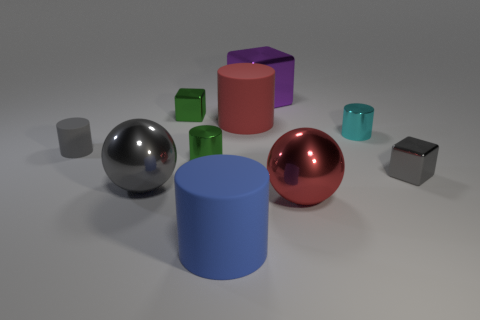Does the big sphere to the left of the large red metal ball have the same material as the tiny gray cylinder?
Provide a short and direct response. No. What is the material of the tiny cylinder that is on the right side of the tiny gray matte cylinder and to the left of the purple cube?
Your answer should be very brief. Metal. What color is the matte object that is to the left of the tiny object that is behind the red rubber object?
Give a very brief answer. Gray. What material is the gray object that is the same shape as the red metallic thing?
Offer a terse response. Metal. There is a tiny thing that is to the left of the metallic object left of the small green metal thing behind the small matte thing; what color is it?
Give a very brief answer. Gray. What number of objects are large shiny cubes or tiny purple rubber things?
Provide a succinct answer. 1. How many small brown shiny objects have the same shape as the purple thing?
Your response must be concise. 0. Is the green cube made of the same material as the gray thing that is right of the cyan metallic cylinder?
Give a very brief answer. Yes. There is a red object that is the same material as the small gray cylinder; what is its size?
Ensure brevity in your answer.  Large. There is a rubber cylinder on the left side of the green cylinder; what is its size?
Your answer should be compact. Small. 